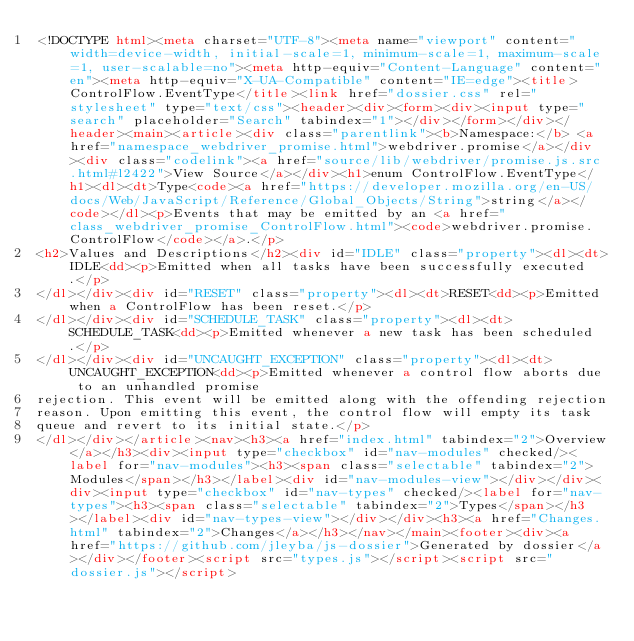<code> <loc_0><loc_0><loc_500><loc_500><_HTML_><!DOCTYPE html><meta charset="UTF-8"><meta name="viewport" content="width=device-width, initial-scale=1, minimum-scale=1, maximum-scale=1, user-scalable=no"><meta http-equiv="Content-Language" content="en"><meta http-equiv="X-UA-Compatible" content="IE=edge"><title>ControlFlow.EventType</title><link href="dossier.css" rel="stylesheet" type="text/css"><header><div><form><div><input type="search" placeholder="Search" tabindex="1"></div></form></div></header><main><article><div class="parentlink"><b>Namespace:</b> <a href="namespace_webdriver_promise.html">webdriver.promise</a></div><div class="codelink"><a href="source/lib/webdriver/promise.js.src.html#l2422">View Source</a></div><h1>enum ControlFlow.EventType</h1><dl><dt>Type<code><a href="https://developer.mozilla.org/en-US/docs/Web/JavaScript/Reference/Global_Objects/String">string</a></code></dl><p>Events that may be emitted by an <a href="class_webdriver_promise_ControlFlow.html"><code>webdriver.promise.ControlFlow</code></a>.</p>
<h2>Values and Descriptions</h2><div id="IDLE" class="property"><dl><dt>IDLE<dd><p>Emitted when all tasks have been successfully executed.</p>
</dl></div><div id="RESET" class="property"><dl><dt>RESET<dd><p>Emitted when a ControlFlow has been reset.</p>
</dl></div><div id="SCHEDULE_TASK" class="property"><dl><dt>SCHEDULE_TASK<dd><p>Emitted whenever a new task has been scheduled.</p>
</dl></div><div id="UNCAUGHT_EXCEPTION" class="property"><dl><dt>UNCAUGHT_EXCEPTION<dd><p>Emitted whenever a control flow aborts due to an unhandled promise
rejection. This event will be emitted along with the offending rejection
reason. Upon emitting this event, the control flow will empty its task
queue and revert to its initial state.</p>
</dl></div></article><nav><h3><a href="index.html" tabindex="2">Overview</a></h3><div><input type="checkbox" id="nav-modules" checked/><label for="nav-modules"><h3><span class="selectable" tabindex="2">Modules</span></h3></label><div id="nav-modules-view"></div></div><div><input type="checkbox" id="nav-types" checked/><label for="nav-types"><h3><span class="selectable" tabindex="2">Types</span></h3></label><div id="nav-types-view"></div></div><h3><a href="Changes.html" tabindex="2">Changes</a></h3></nav></main><footer><div><a href="https://github.com/jleyba/js-dossier">Generated by dossier</a></div></footer><script src="types.js"></script><script src="dossier.js"></script></code> 